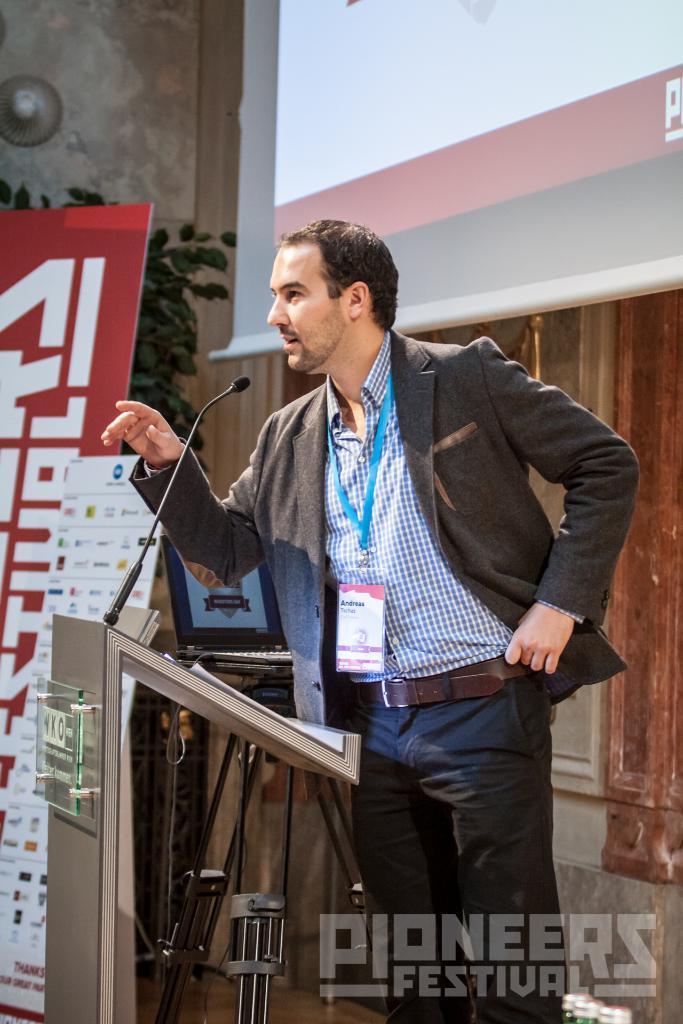In one or two sentences, can you explain what this image depicts? In the image we can see a man standing, wearing clothes and identity card. In front of him there is a podium and this is a microphone. This is a poster, plant, projected screen and a watermark. 